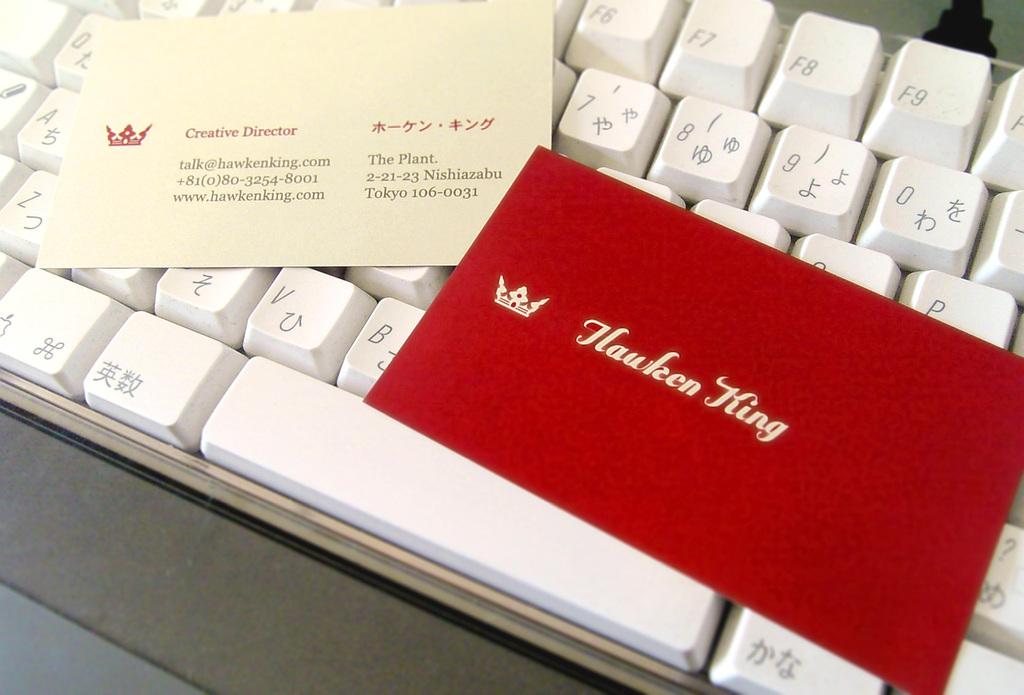Who is the red envelope addressed to?
Ensure brevity in your answer.  Hauken king. What is his job title?
Your answer should be very brief. Creative director. 